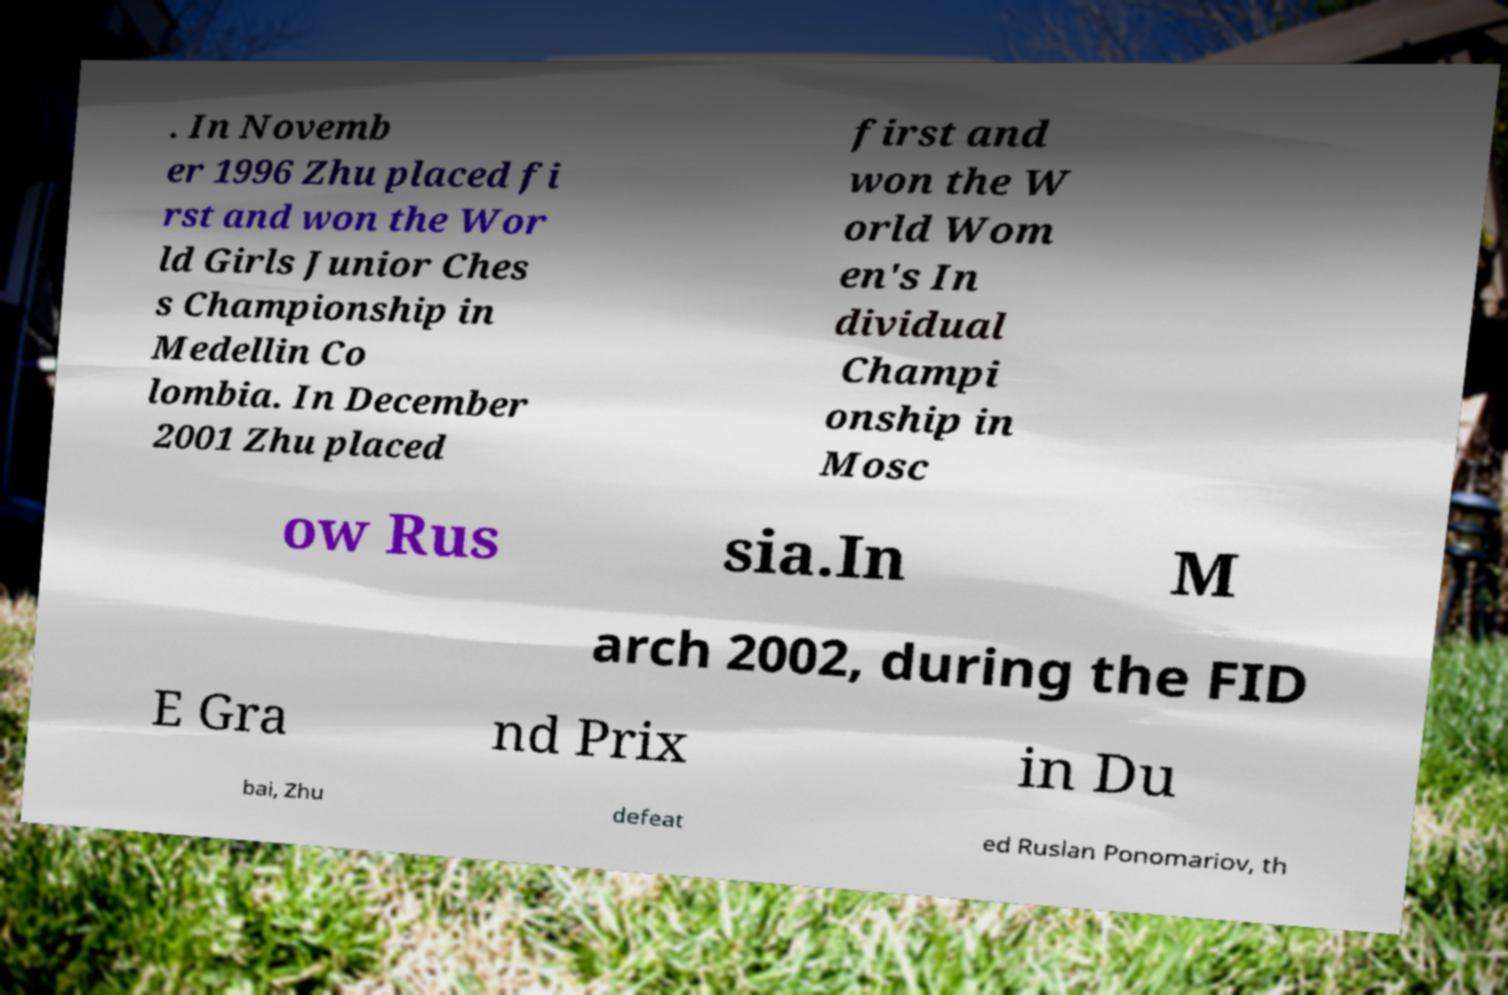There's text embedded in this image that I need extracted. Can you transcribe it verbatim? . In Novemb er 1996 Zhu placed fi rst and won the Wor ld Girls Junior Ches s Championship in Medellin Co lombia. In December 2001 Zhu placed first and won the W orld Wom en's In dividual Champi onship in Mosc ow Rus sia.In M arch 2002, during the FID E Gra nd Prix in Du bai, Zhu defeat ed Ruslan Ponomariov, th 